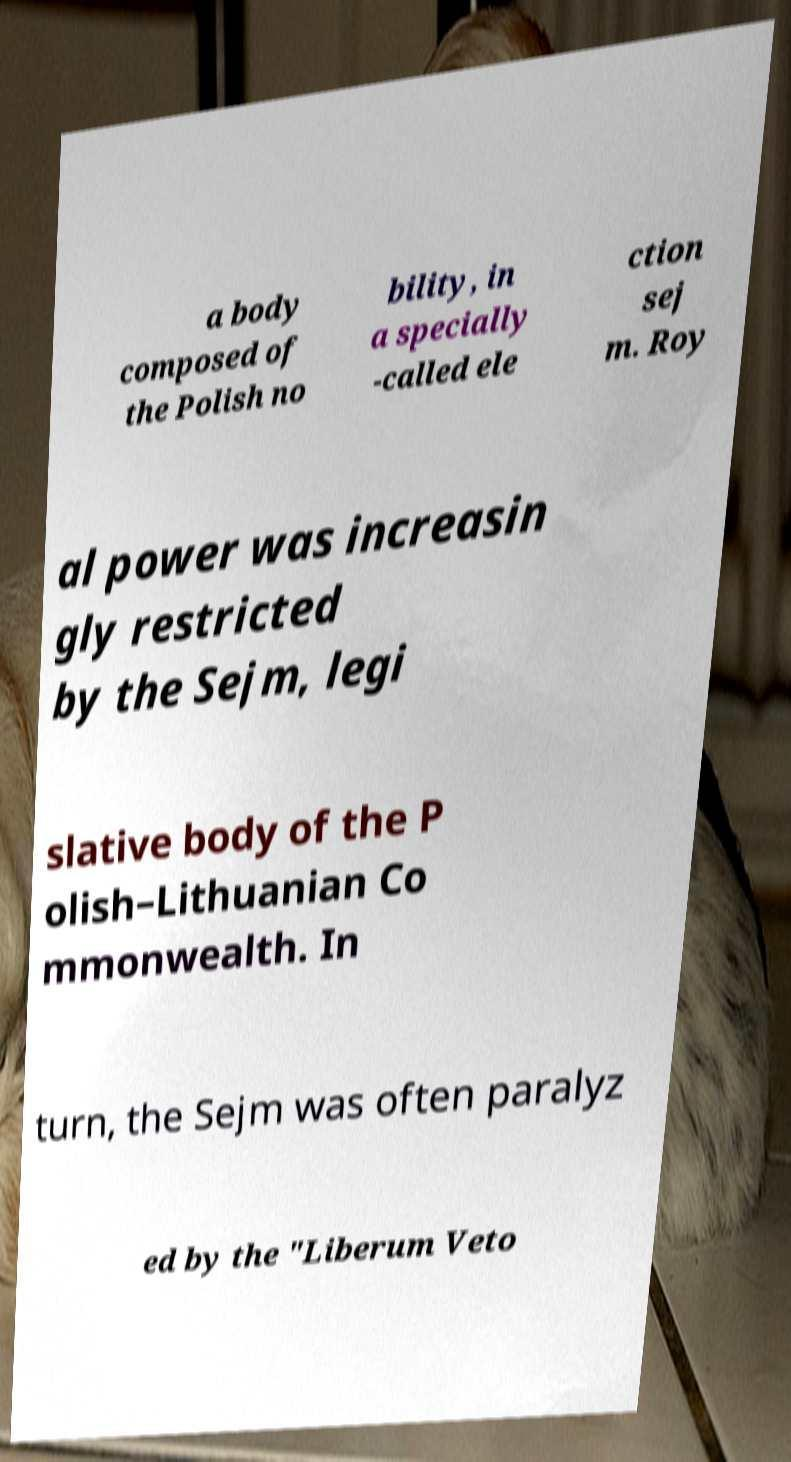Could you assist in decoding the text presented in this image and type it out clearly? a body composed of the Polish no bility, in a specially -called ele ction sej m. Roy al power was increasin gly restricted by the Sejm, legi slative body of the P olish–Lithuanian Co mmonwealth. In turn, the Sejm was often paralyz ed by the "Liberum Veto 